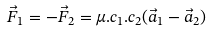Convert formula to latex. <formula><loc_0><loc_0><loc_500><loc_500>\vec { F } _ { 1 } = - \vec { F } _ { 2 } = \mu . c _ { 1 } . c _ { 2 } ( \vec { a } _ { 1 } - \vec { a } _ { 2 } )</formula> 